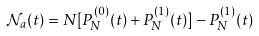Convert formula to latex. <formula><loc_0><loc_0><loc_500><loc_500>\mathcal { N } _ { a } ( t ) = N [ P _ { N } ^ { ( 0 ) } ( t ) + P _ { N } ^ { ( 1 ) } ( t ) ] - P _ { N } ^ { ( 1 ) } ( t )</formula> 